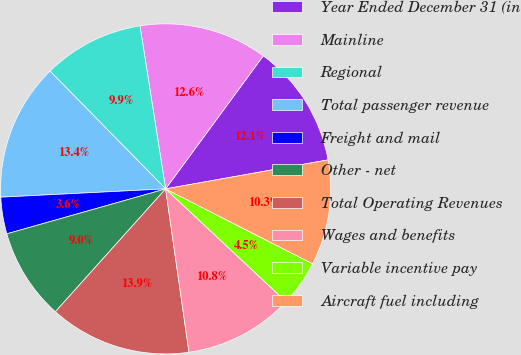Convert chart. <chart><loc_0><loc_0><loc_500><loc_500><pie_chart><fcel>Year Ended December 31 (in<fcel>Mainline<fcel>Regional<fcel>Total passenger revenue<fcel>Freight and mail<fcel>Other - net<fcel>Total Operating Revenues<fcel>Wages and benefits<fcel>Variable incentive pay<fcel>Aircraft fuel including<nl><fcel>12.11%<fcel>12.56%<fcel>9.87%<fcel>13.45%<fcel>3.59%<fcel>8.97%<fcel>13.9%<fcel>10.76%<fcel>4.48%<fcel>10.31%<nl></chart> 